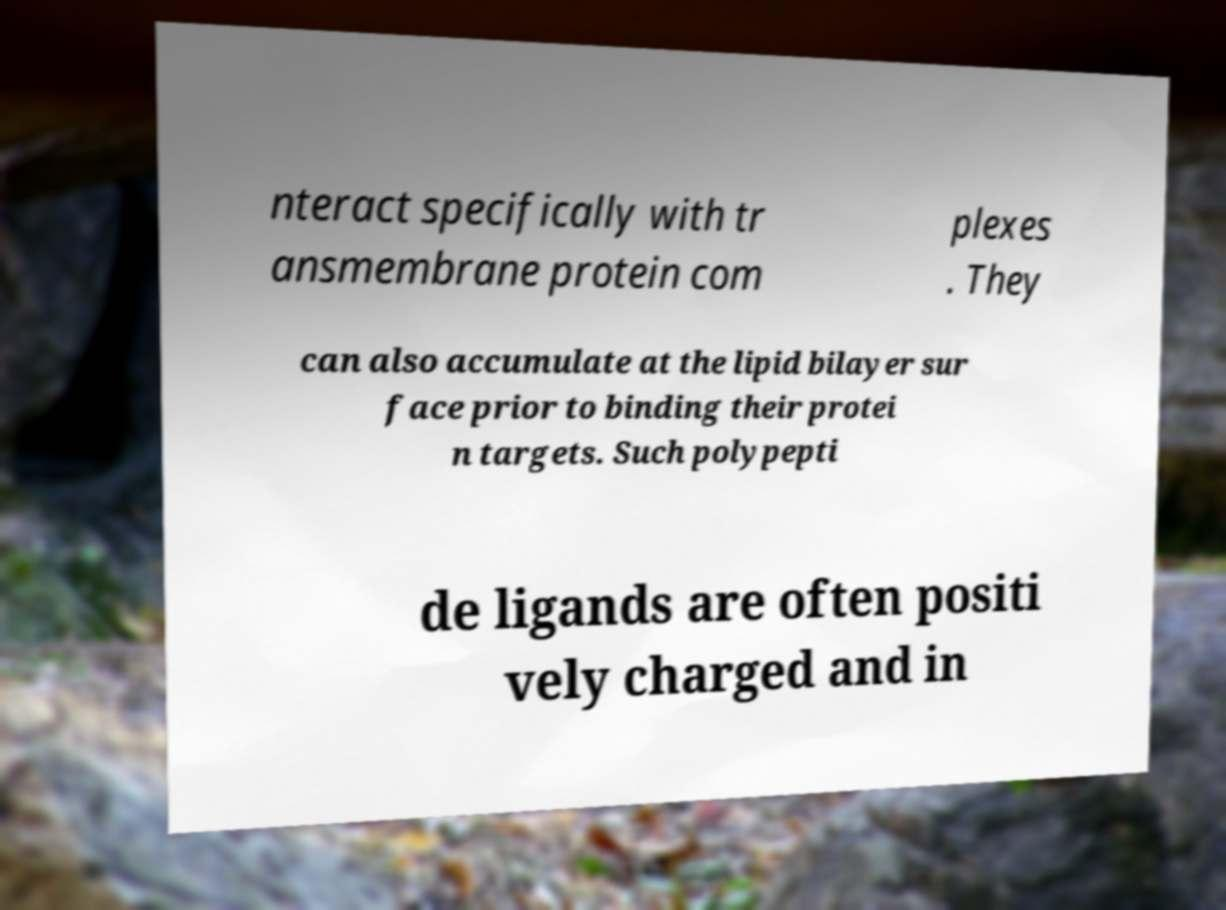Could you extract and type out the text from this image? nteract specifically with tr ansmembrane protein com plexes . They can also accumulate at the lipid bilayer sur face prior to binding their protei n targets. Such polypepti de ligands are often positi vely charged and in 